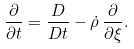<formula> <loc_0><loc_0><loc_500><loc_500>\frac { \partial } { \partial t } = \frac { D } { D t } - \dot { \rho } \, \frac { \partial } { \partial \xi } .</formula> 